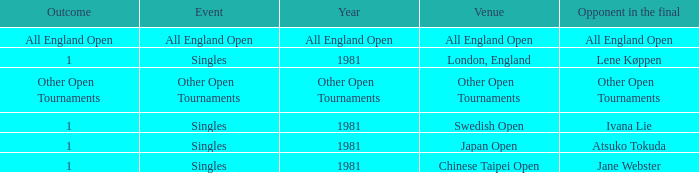Who was the rival in london, england with an outcome of 1? Lene Køppen. 